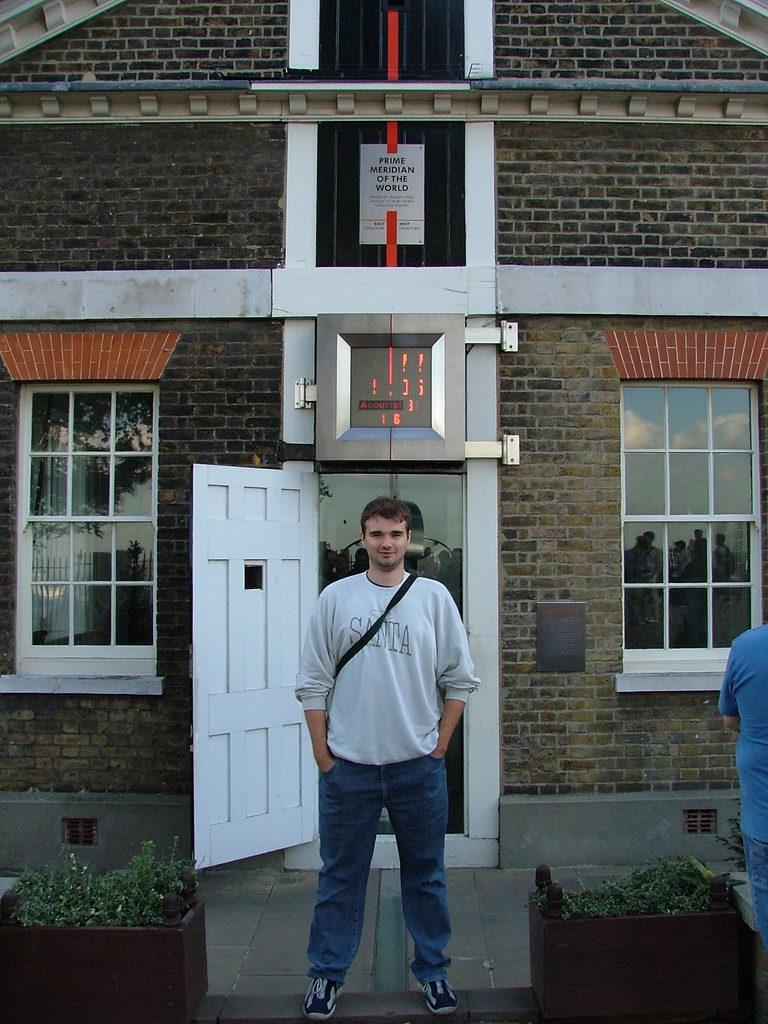<image>
Render a clear and concise summary of the photo. Man wearing a sweater that says Santa in front of a building. 